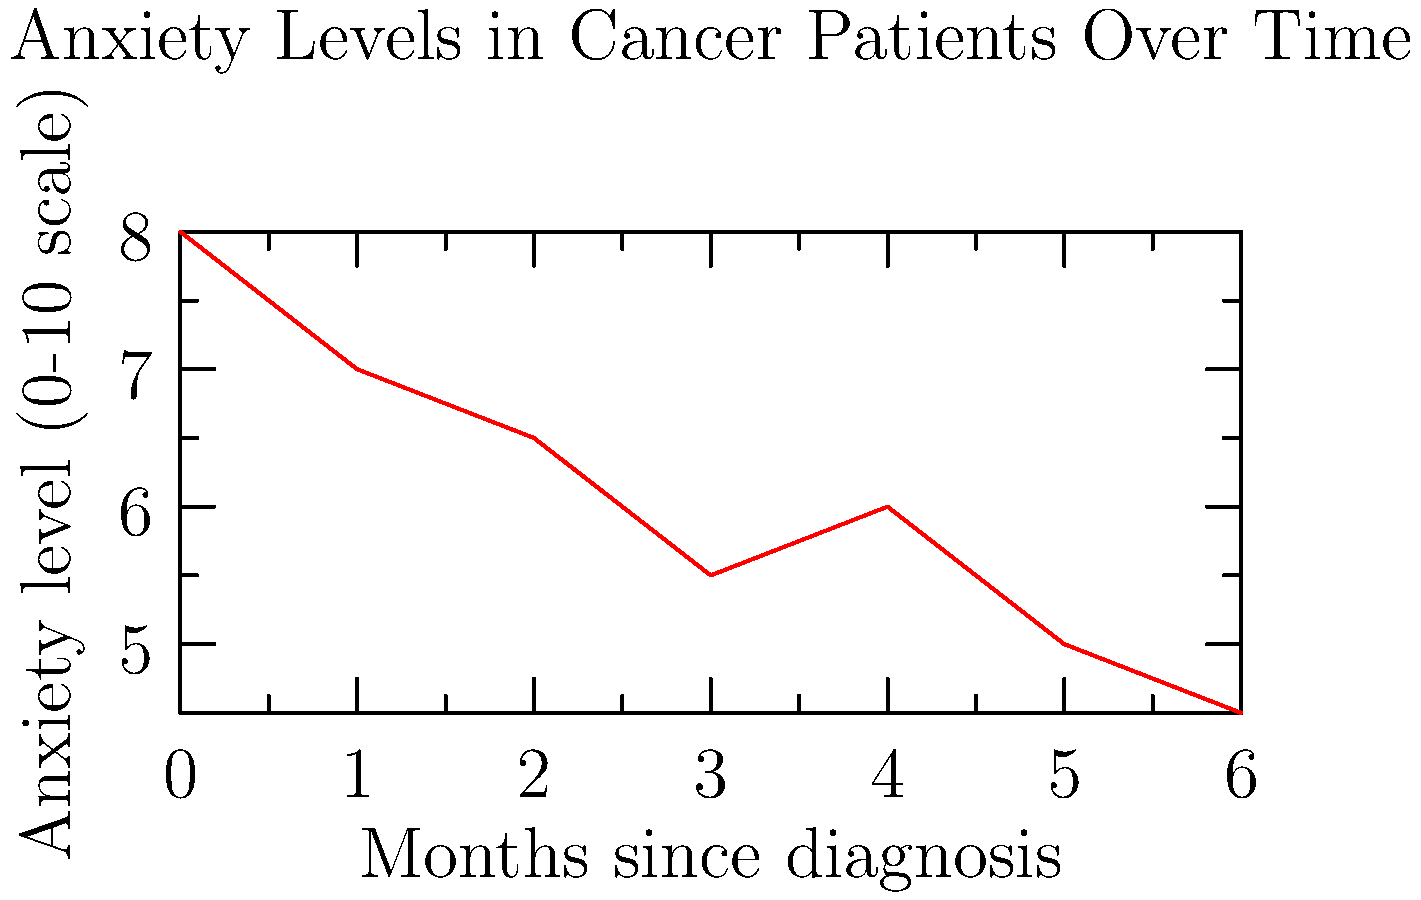Based on the line graph showing anxiety levels in cancer patients over time, what is the overall trend in anxiety levels from the time of diagnosis to 6 months later? To determine the overall trend in anxiety levels, we need to analyze the graph from left to right:

1. At month 0 (diagnosis), the anxiety level starts at 8 on a 0-10 scale.
2. Over the next 3 months, there is a steady decrease in anxiety levels:
   - Month 1: anxiety level drops to 7
   - Month 2: anxiety level further decreases to 6.5
   - Month 3: anxiety level continues to drop to 5.5
3. There is a slight increase at month 4, where anxiety levels rise to 6.
4. However, this increase is temporary, and the downward trend resumes:
   - Month 5: anxiety level drops back to 5
   - Month 6: anxiety level reaches its lowest point at 4.5

Despite the small fluctuation at month 4, the overall trend from the beginning (8) to the end (4.5) of the 6-month period shows a clear decrease in anxiety levels.
Answer: Decreasing 